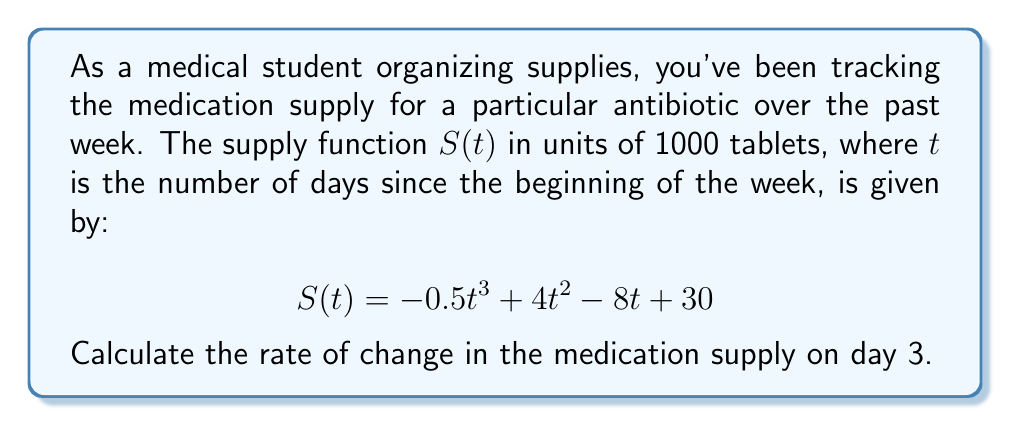Teach me how to tackle this problem. To find the rate of change in the medication supply on day 3, we need to follow these steps:

1) The rate of change at any point is given by the first derivative of the function. Let's call this derivative $S'(t)$.

2) To find $S'(t)$, we differentiate $S(t)$ with respect to $t$:
   
   $$S'(t) = \frac{d}{dt}(-0.5t^3 + 4t^2 - 8t + 30)$$
   
   $$S'(t) = -1.5t^2 + 8t - 8$$

3) Now that we have the rate of change function, we need to evaluate it at $t = 3$:
   
   $$S'(3) = -1.5(3)^2 + 8(3) - 8$$
   
   $$S'(3) = -1.5(9) + 24 - 8$$
   
   $$S'(3) = -13.5 + 24 - 8$$
   
   $$S'(3) = 2.5$$

4) The units of the rate of change will be in thousands of tablets per day.

Therefore, on day 3, the rate of change in the medication supply is 2.5 thousand tablets per day, or an increase of 2,500 tablets per day.
Answer: 2.5 thousand tablets/day 